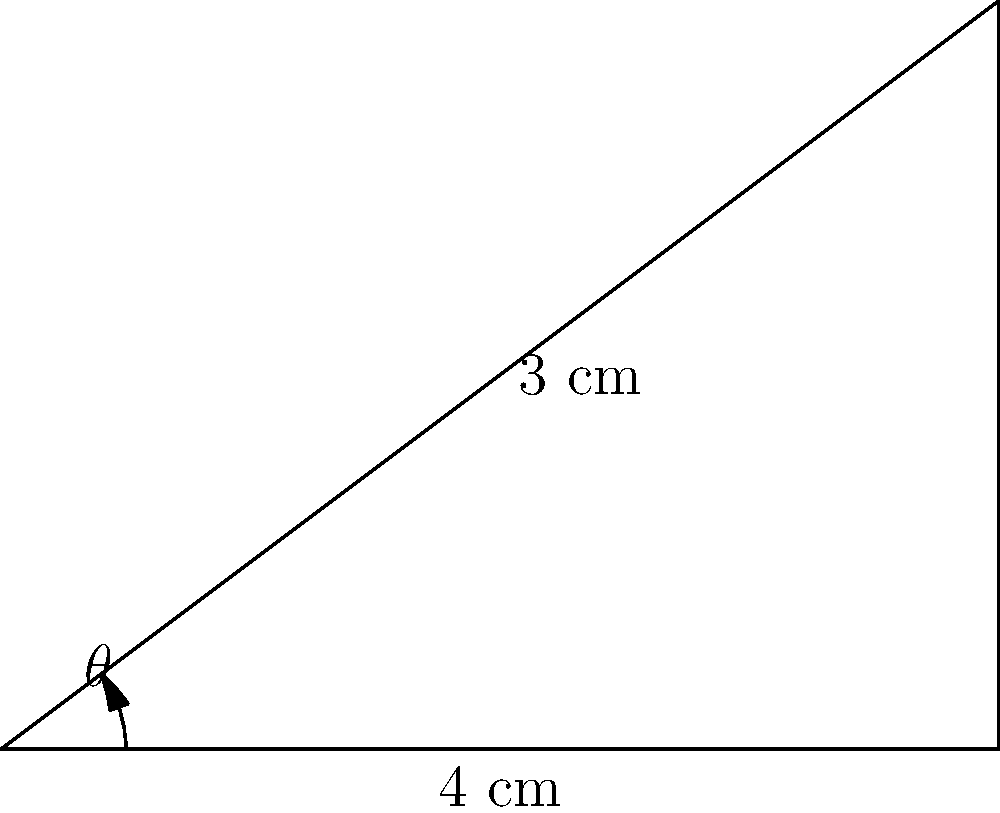As a jazz pianist, you're fascinated by the mechanics of your instrument. You notice that when a piano key is pressed, it rotates around a pivot point. If the key is 4 cm long and the far end rises 3 cm when fully pressed, what is the angle of rotation ($\theta$) of the key? Let's approach this step-by-step:

1) The key's movement forms a right-angled triangle. The length of the key (4 cm) is the base of this triangle, and the height the key rises (3 cm) is the opposite side.

2) We need to find the angle $\theta$ between the base and the hypotenuse. This is a perfect scenario for using the tangent function.

3) The tangent of an angle in a right-angled triangle is the ratio of the opposite side to the adjacent side:

   $\tan(\theta) = \frac{\text{opposite}}{\text{adjacent}} = \frac{3}{4}$

4) To find $\theta$, we need to use the inverse tangent (arctangent) function:

   $\theta = \tan^{-1}(\frac{3}{4})$

5) Using a calculator or computer:

   $\theta = \tan^{-1}(\frac{3}{4}) \approx 36.87°$

6) Round to the nearest degree:

   $\theta \approx 37°$

This angle represents the rotation of the piano key from its resting position to fully pressed.
Answer: $37°$ 